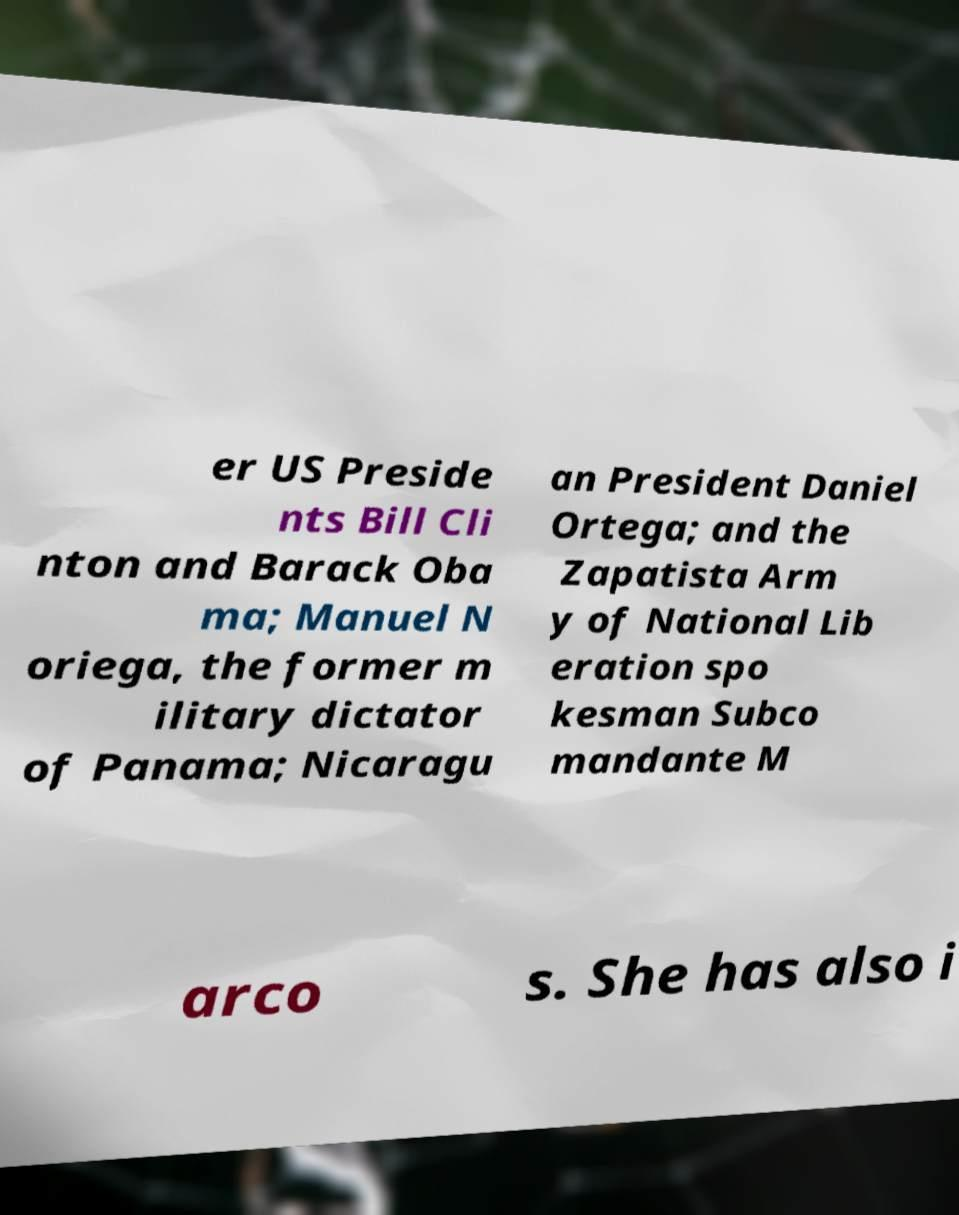There's text embedded in this image that I need extracted. Can you transcribe it verbatim? er US Preside nts Bill Cli nton and Barack Oba ma; Manuel N oriega, the former m ilitary dictator of Panama; Nicaragu an President Daniel Ortega; and the Zapatista Arm y of National Lib eration spo kesman Subco mandante M arco s. She has also i 